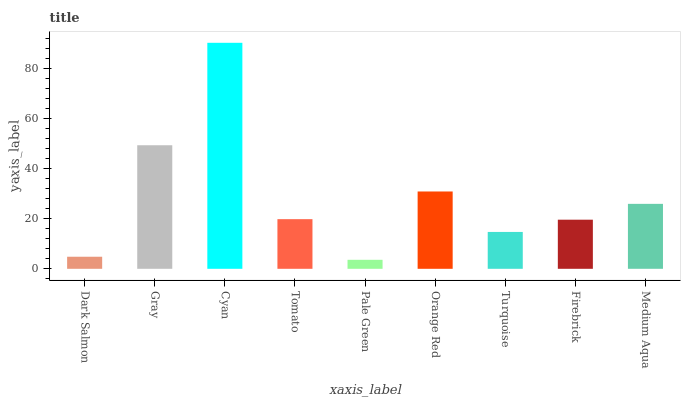Is Pale Green the minimum?
Answer yes or no. Yes. Is Cyan the maximum?
Answer yes or no. Yes. Is Gray the minimum?
Answer yes or no. No. Is Gray the maximum?
Answer yes or no. No. Is Gray greater than Dark Salmon?
Answer yes or no. Yes. Is Dark Salmon less than Gray?
Answer yes or no. Yes. Is Dark Salmon greater than Gray?
Answer yes or no. No. Is Gray less than Dark Salmon?
Answer yes or no. No. Is Tomato the high median?
Answer yes or no. Yes. Is Tomato the low median?
Answer yes or no. Yes. Is Pale Green the high median?
Answer yes or no. No. Is Gray the low median?
Answer yes or no. No. 